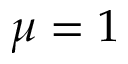Convert formula to latex. <formula><loc_0><loc_0><loc_500><loc_500>\mu = 1</formula> 